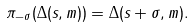<formula> <loc_0><loc_0><loc_500><loc_500>\pi _ { - \sigma } ( \Delta ( s , m ) ) = \Delta ( s + \sigma , m ) .</formula> 